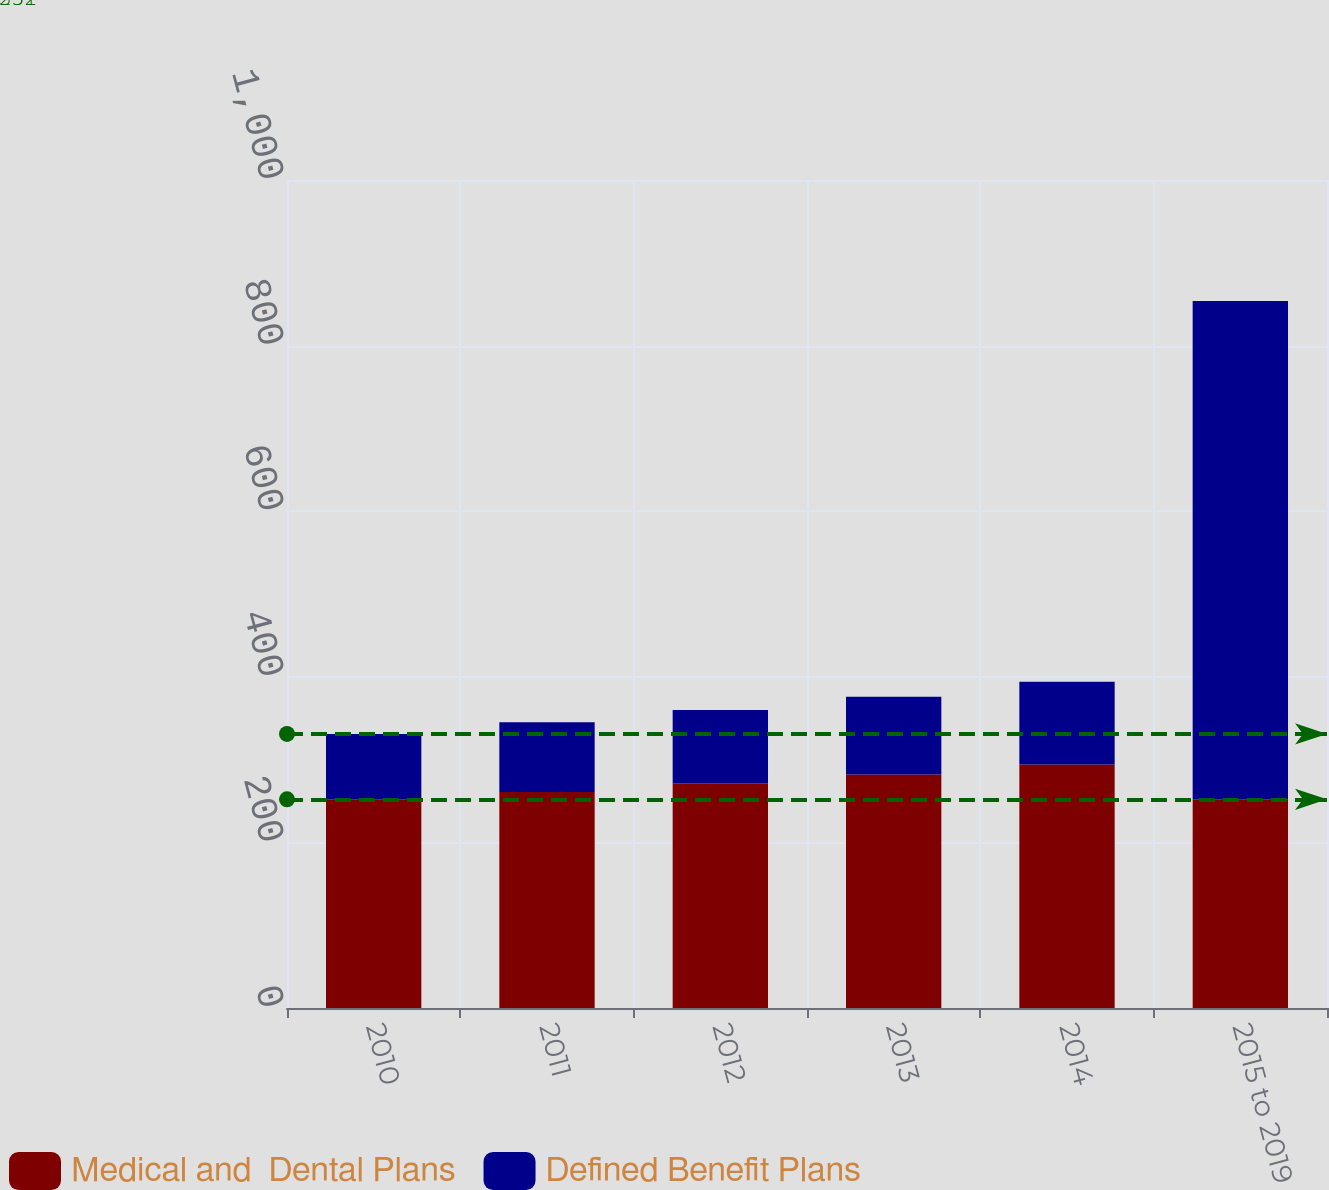Convert chart to OTSL. <chart><loc_0><loc_0><loc_500><loc_500><stacked_bar_chart><ecel><fcel>2010<fcel>2011<fcel>2012<fcel>2013<fcel>2014<fcel>2015 to 2019<nl><fcel>Medical and  Dental Plans<fcel>252<fcel>261<fcel>271<fcel>282<fcel>294<fcel>252<nl><fcel>Defined Benefit Plans<fcel>79<fcel>84<fcel>89<fcel>94<fcel>100<fcel>602<nl></chart> 